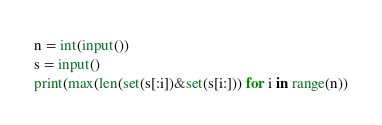<code> <loc_0><loc_0><loc_500><loc_500><_Python_>n = int(input())
s = input()
print(max(len(set(s[:i])&set(s[i:])) for i in range(n))</code> 